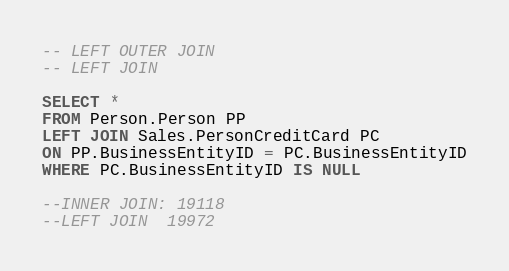<code> <loc_0><loc_0><loc_500><loc_500><_SQL_>-- LEFT OUTER JOIN
-- LEFT JOIN

SELECT *
FROM Person.Person PP
LEFT JOIN Sales.PersonCreditCard PC
ON PP.BusinessEntityID = PC.BusinessEntityID
WHERE PC.BusinessEntityID IS NULL

--INNER JOIN: 19118
--LEFT JOIN  19972



</code> 